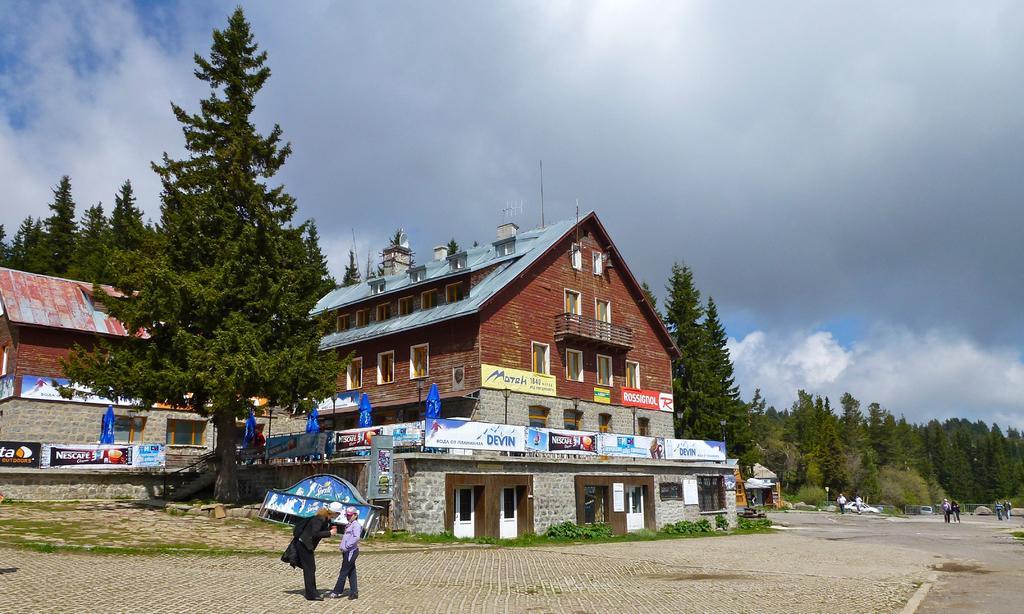In one or two sentences, can you explain what this image depicts? In the image we can see there are buildings and these are the windows of the building. This is a fence, footpath, trees, doors and a cloudy pale blue sky. We can see there are even people standing and some of them are walking, they are wearing clothes and some of them are wearing a cap. This is grass. 